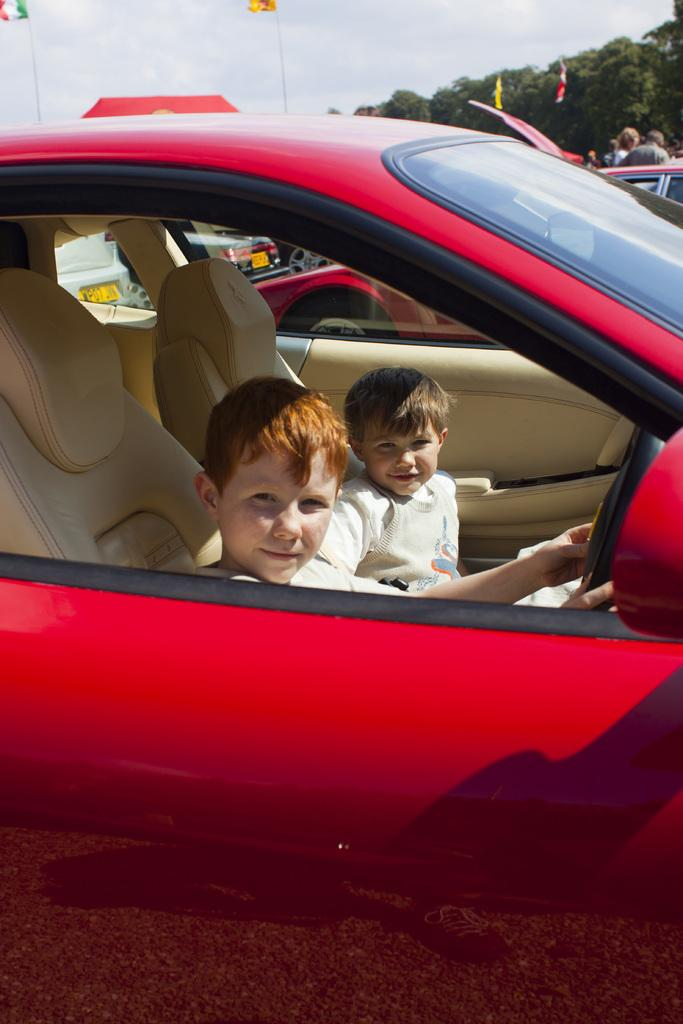How many kids are in the image? There are two kids in the image. What are the kids doing in the image? The kids are sitting in the seats of a red colored car. What can be seen in the background of the image? There are trees and the sky visible in the background of the image. What type of liquid is being spilled by the kids in the image? There is no liquid being spilled by the kids in the image; they are sitting in the seats of a red colored car. 